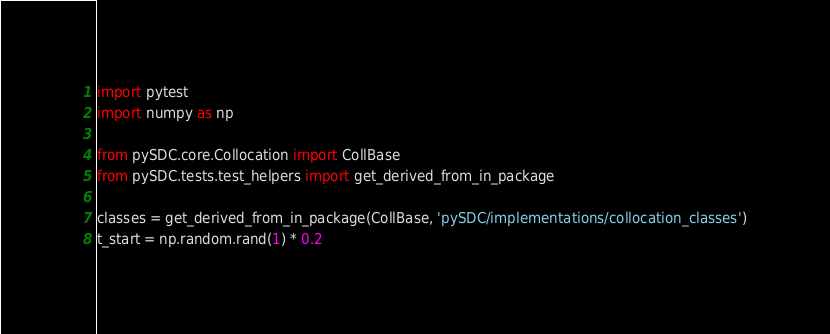Convert code to text. <code><loc_0><loc_0><loc_500><loc_500><_Python_>import pytest
import numpy as np

from pySDC.core.Collocation import CollBase
from pySDC.tests.test_helpers import get_derived_from_in_package

classes = get_derived_from_in_package(CollBase, 'pySDC/implementations/collocation_classes')
t_start = np.random.rand(1) * 0.2</code> 